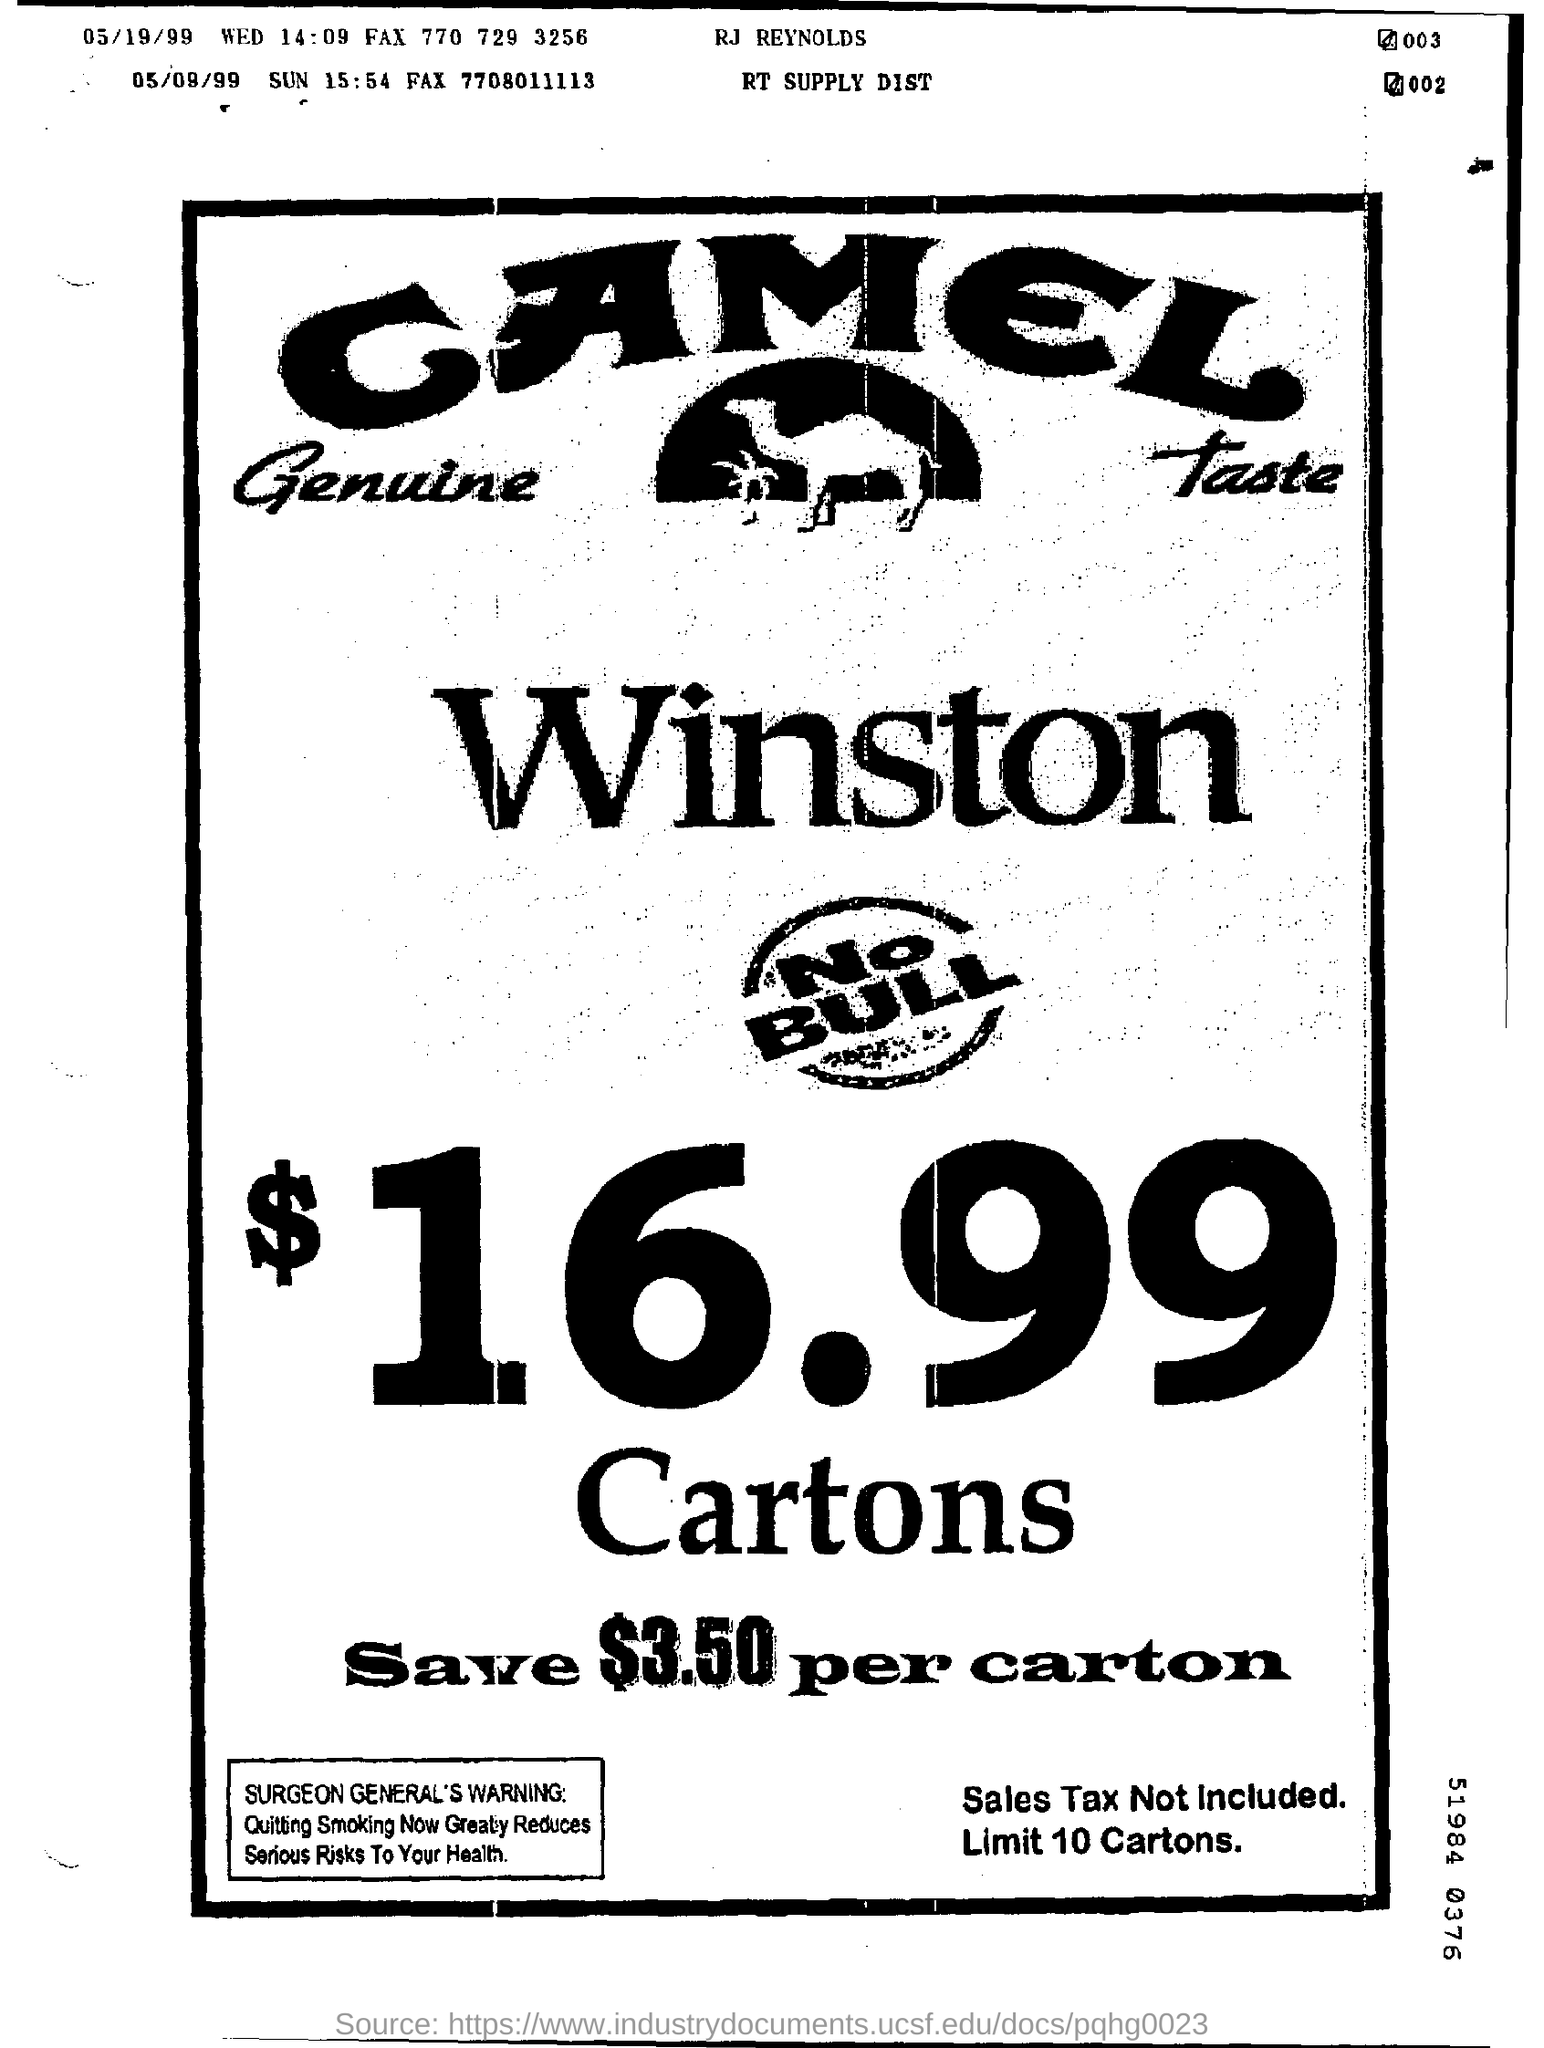Point out several critical features in this image. The date mentioned in the line where RJ Reynolds is printed is May 19, 1999. On May 19, 1999, the date was Wednesday. 